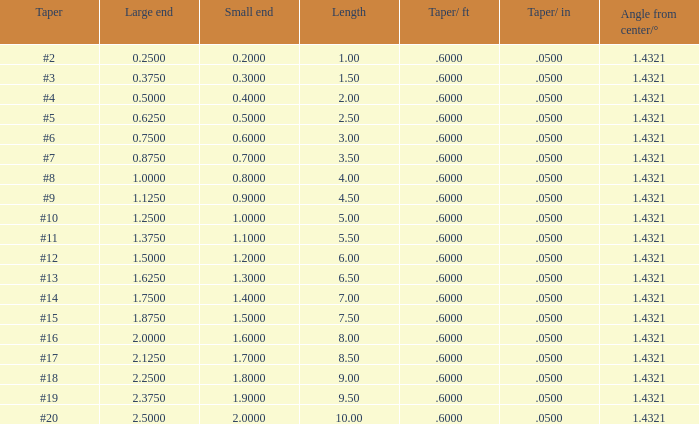375? None. 